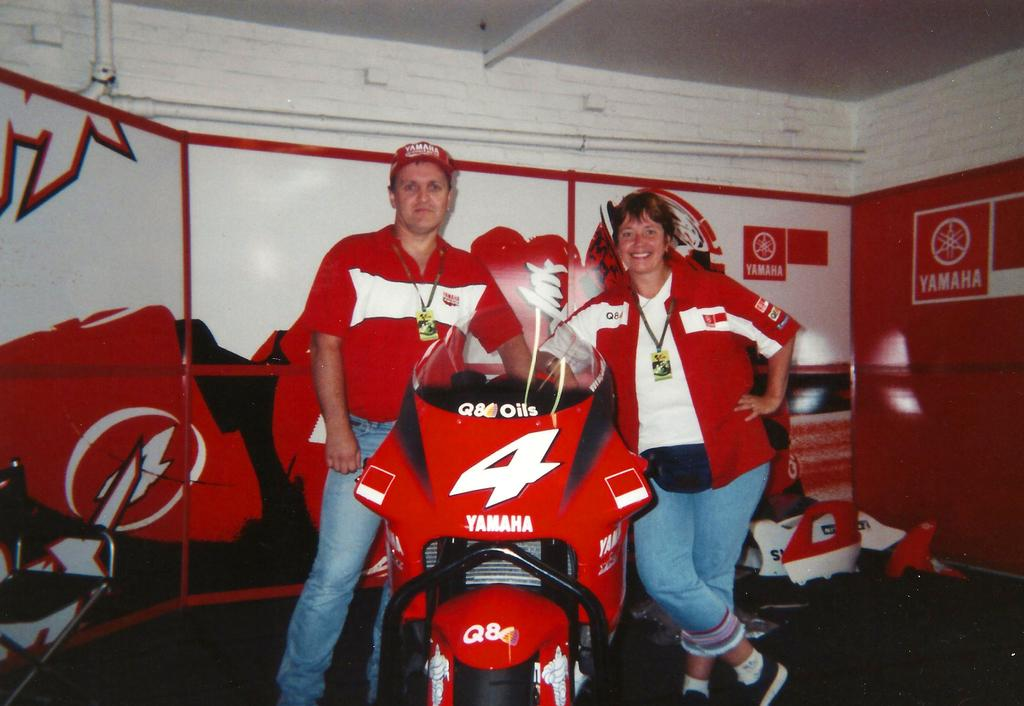<image>
Offer a succinct explanation of the picture presented. Yamaha is the corporate sponsor for the racing bike. 